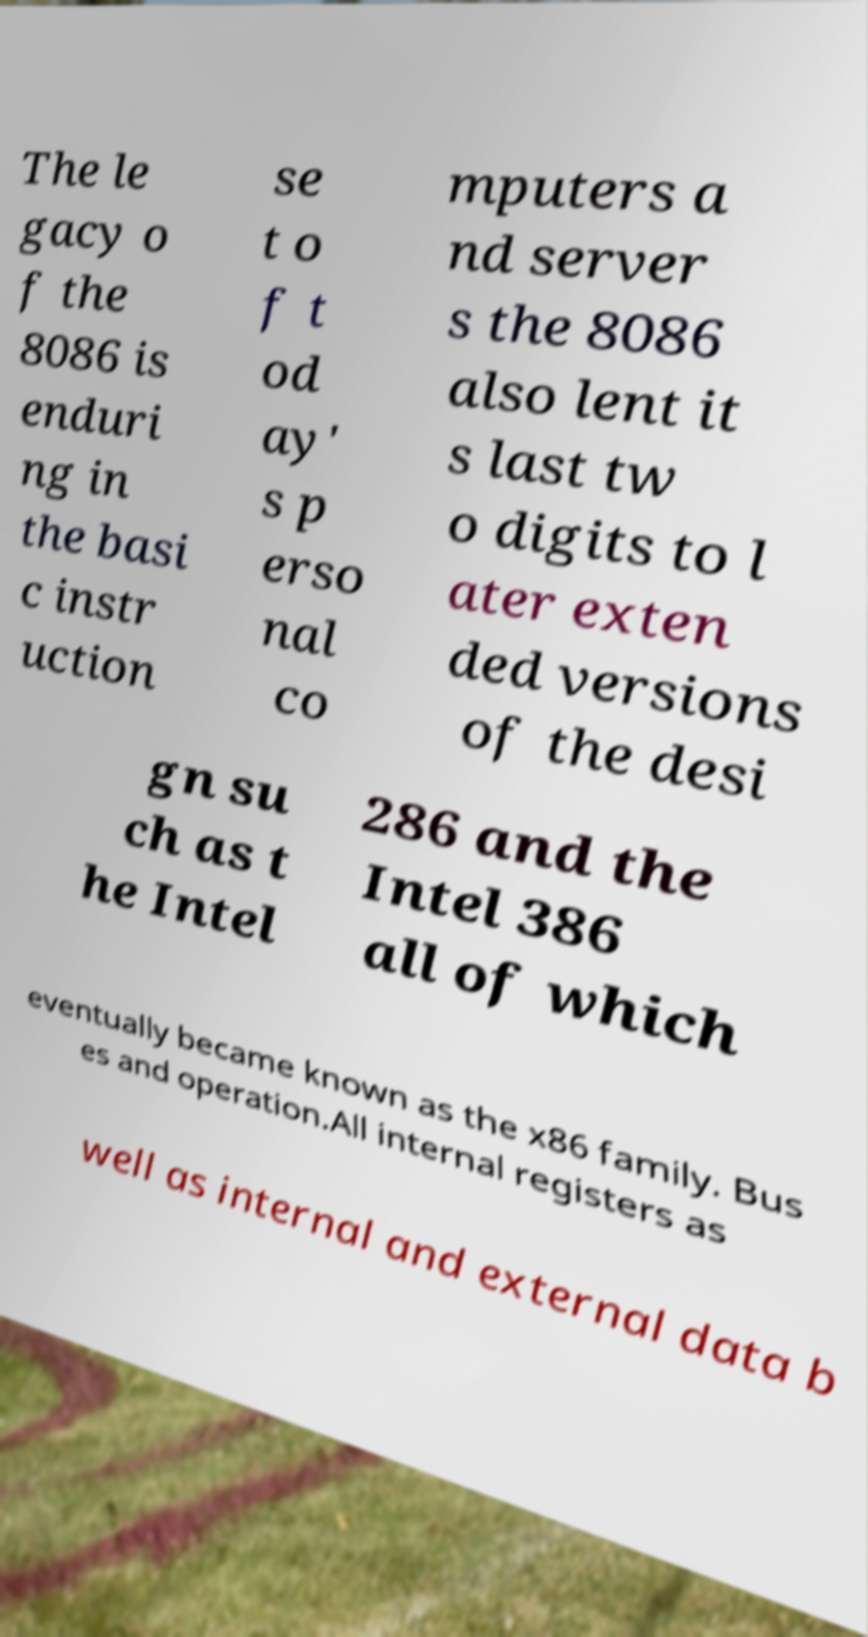Can you read and provide the text displayed in the image?This photo seems to have some interesting text. Can you extract and type it out for me? The le gacy o f the 8086 is enduri ng in the basi c instr uction se t o f t od ay' s p erso nal co mputers a nd server s the 8086 also lent it s last tw o digits to l ater exten ded versions of the desi gn su ch as t he Intel 286 and the Intel 386 all of which eventually became known as the x86 family. Bus es and operation.All internal registers as well as internal and external data b 